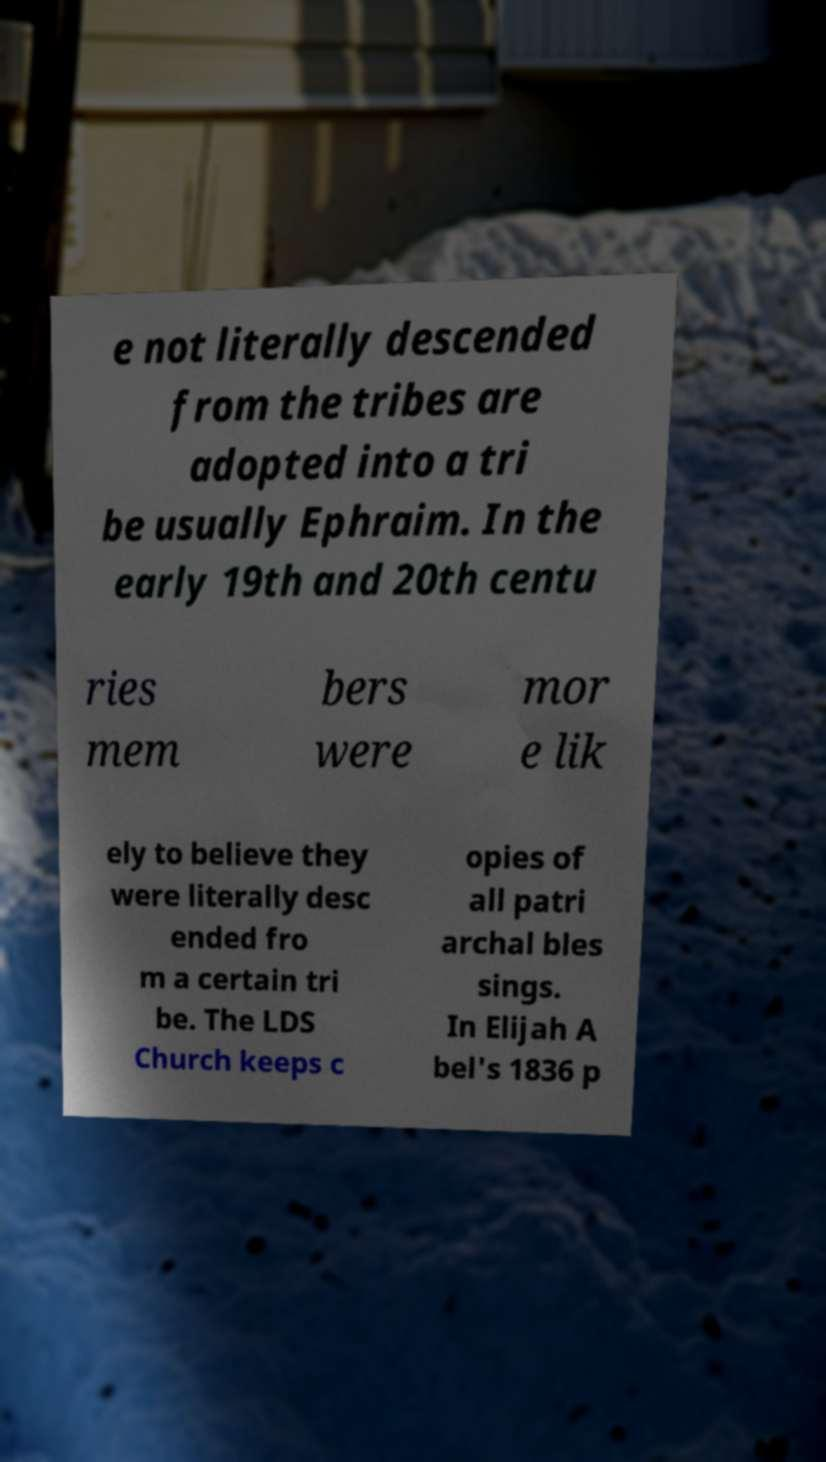There's text embedded in this image that I need extracted. Can you transcribe it verbatim? e not literally descended from the tribes are adopted into a tri be usually Ephraim. In the early 19th and 20th centu ries mem bers were mor e lik ely to believe they were literally desc ended fro m a certain tri be. The LDS Church keeps c opies of all patri archal bles sings. In Elijah A bel's 1836 p 